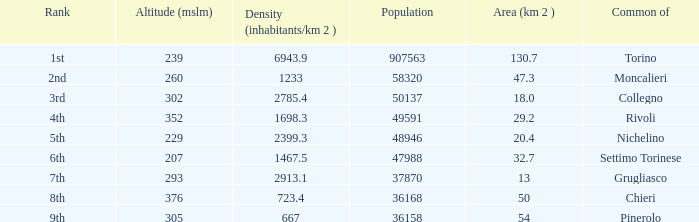How many altitudes does the common with an area of 130.7 km^2 have? 1.0. 